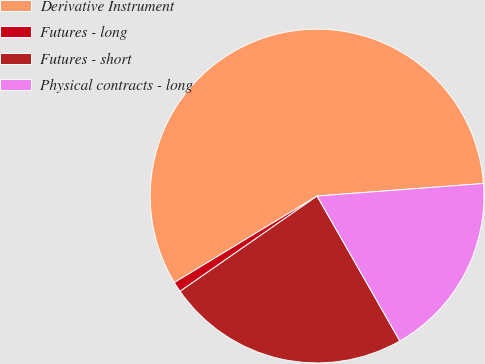Convert chart to OTSL. <chart><loc_0><loc_0><loc_500><loc_500><pie_chart><fcel>Derivative Instrument<fcel>Futures - long<fcel>Futures - short<fcel>Physical contracts - long<nl><fcel>57.48%<fcel>1.0%<fcel>23.59%<fcel>17.94%<nl></chart> 